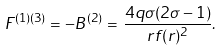Convert formula to latex. <formula><loc_0><loc_0><loc_500><loc_500>F ^ { ( 1 ) ( 3 ) } = - B ^ { ( 2 ) } = \, \frac { 4 q \sigma ( 2 \sigma - 1 ) } { r f ( r ) ^ { 2 } } .</formula> 